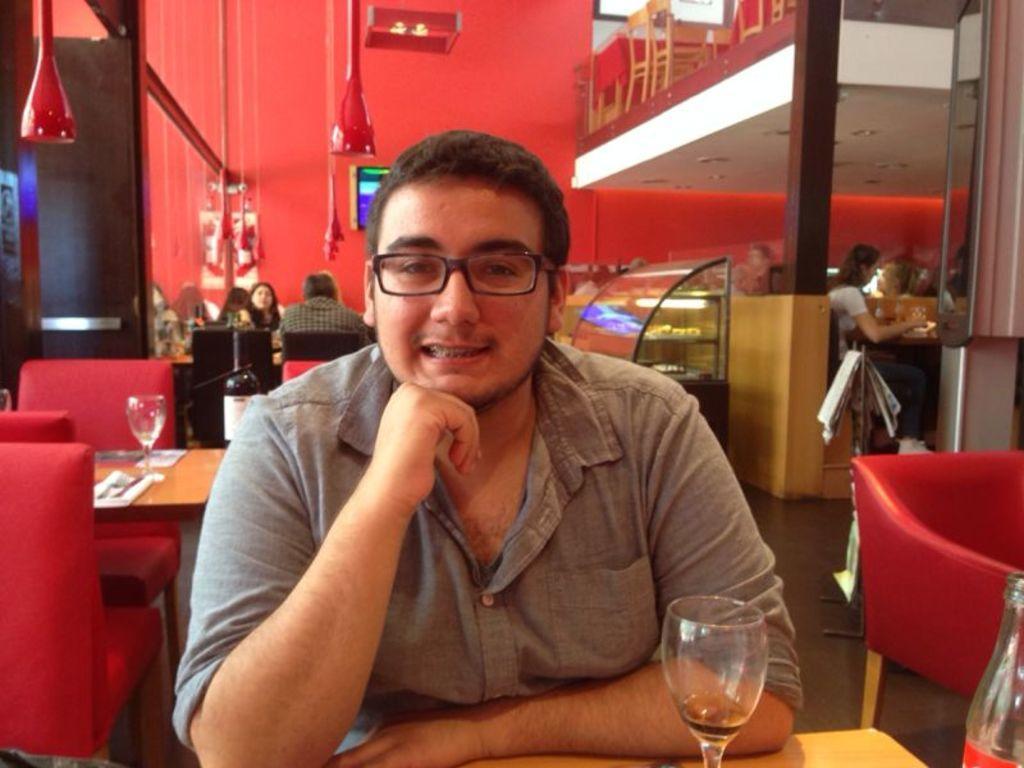How would you summarize this image in a sentence or two? In the image we can see there is a person sitting on the chair and on the table there is a wine glass and wine bottle. Behind there are other people are sitting on the chair. 